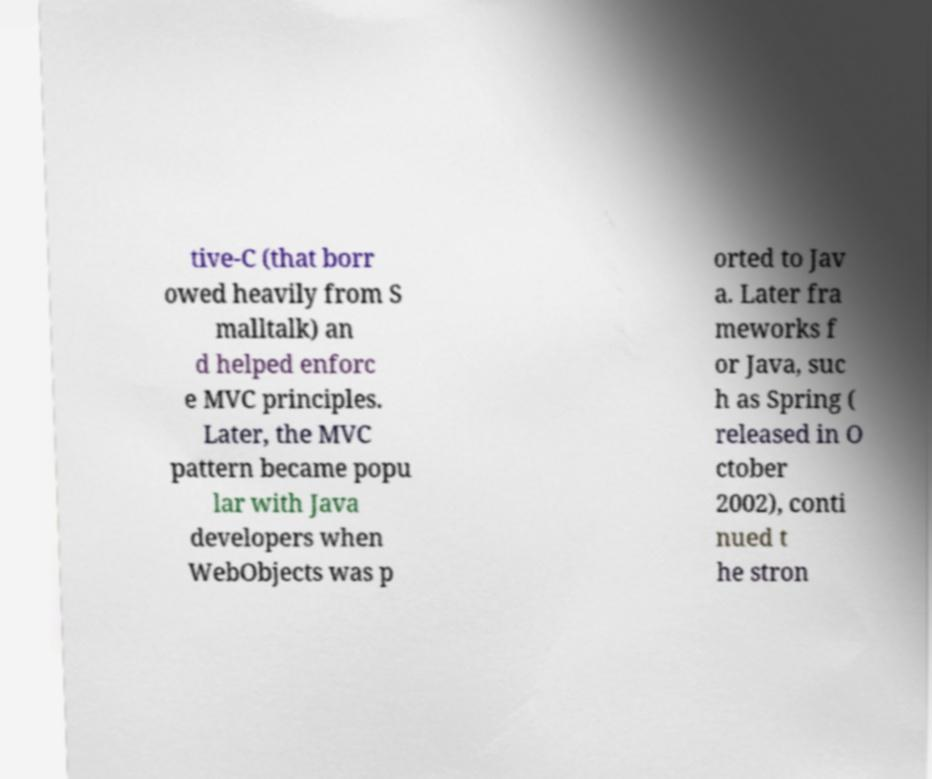I need the written content from this picture converted into text. Can you do that? tive-C (that borr owed heavily from S malltalk) an d helped enforc e MVC principles. Later, the MVC pattern became popu lar with Java developers when WebObjects was p orted to Jav a. Later fra meworks f or Java, suc h as Spring ( released in O ctober 2002), conti nued t he stron 